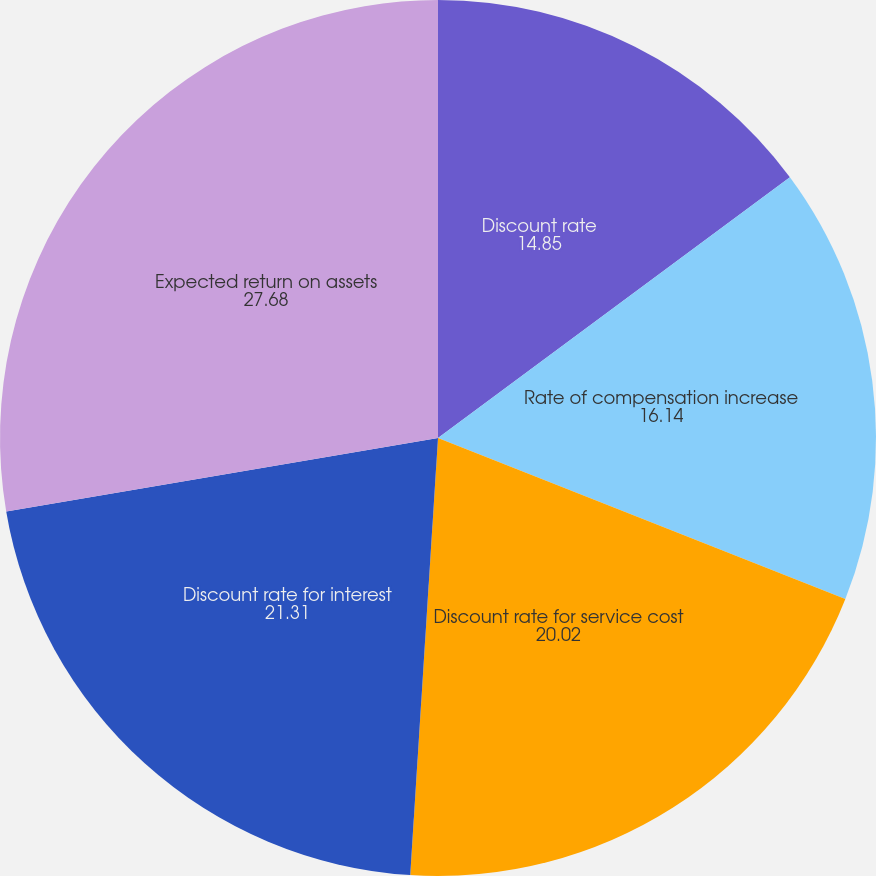Convert chart to OTSL. <chart><loc_0><loc_0><loc_500><loc_500><pie_chart><fcel>Discount rate<fcel>Rate of compensation increase<fcel>Discount rate for service cost<fcel>Discount rate for interest<fcel>Expected return on assets<nl><fcel>14.85%<fcel>16.14%<fcel>20.02%<fcel>21.31%<fcel>27.68%<nl></chart> 